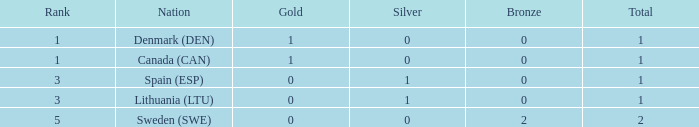What is the total when there were less than 0 bronze? 0.0. Could you parse the entire table as a dict? {'header': ['Rank', 'Nation', 'Gold', 'Silver', 'Bronze', 'Total'], 'rows': [['1', 'Denmark (DEN)', '1', '0', '0', '1'], ['1', 'Canada (CAN)', '1', '0', '0', '1'], ['3', 'Spain (ESP)', '0', '1', '0', '1'], ['3', 'Lithuania (LTU)', '0', '1', '0', '1'], ['5', 'Sweden (SWE)', '0', '0', '2', '2']]} 